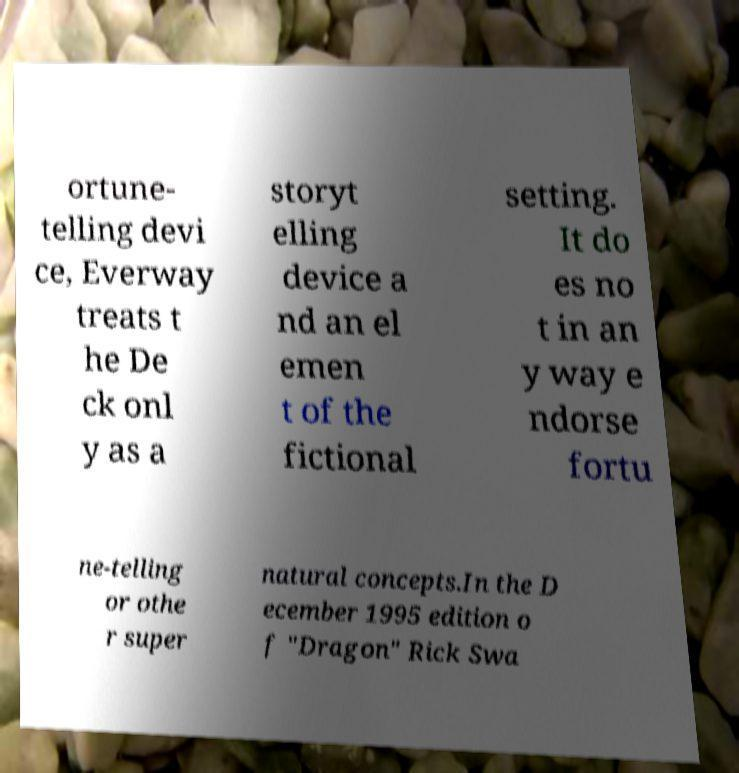For documentation purposes, I need the text within this image transcribed. Could you provide that? ortune- telling devi ce, Everway treats t he De ck onl y as a storyt elling device a nd an el emen t of the fictional setting. It do es no t in an y way e ndorse fortu ne-telling or othe r super natural concepts.In the D ecember 1995 edition o f "Dragon" Rick Swa 